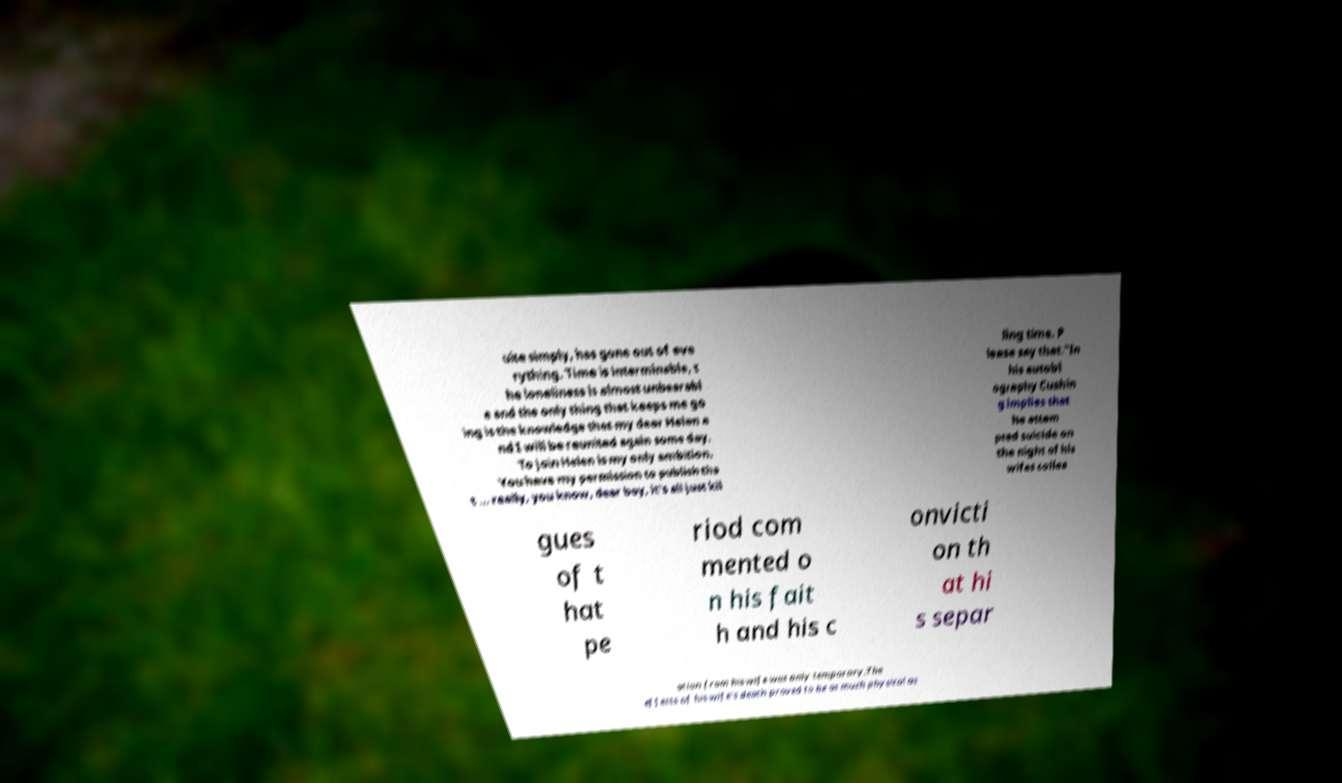Can you read and provide the text displayed in the image?This photo seems to have some interesting text. Can you extract and type it out for me? uite simply, has gone out of eve rything. Time is interminable, t he loneliness is almost unbearabl e and the only thing that keeps me go ing is the knowledge that my dear Helen a nd I will be reunited again some day. To join Helen is my only ambition. You have my permission to publish tha t ... really, you know, dear boy, it's all just kil ling time. P lease say that."In his autobi ography Cushin g implies that he attem pted suicide on the night of his wifes collea gues of t hat pe riod com mented o n his fait h and his c onvicti on th at hi s separ ation from his wife was only temporary.The effects of his wife's death proved to be as much physical as 